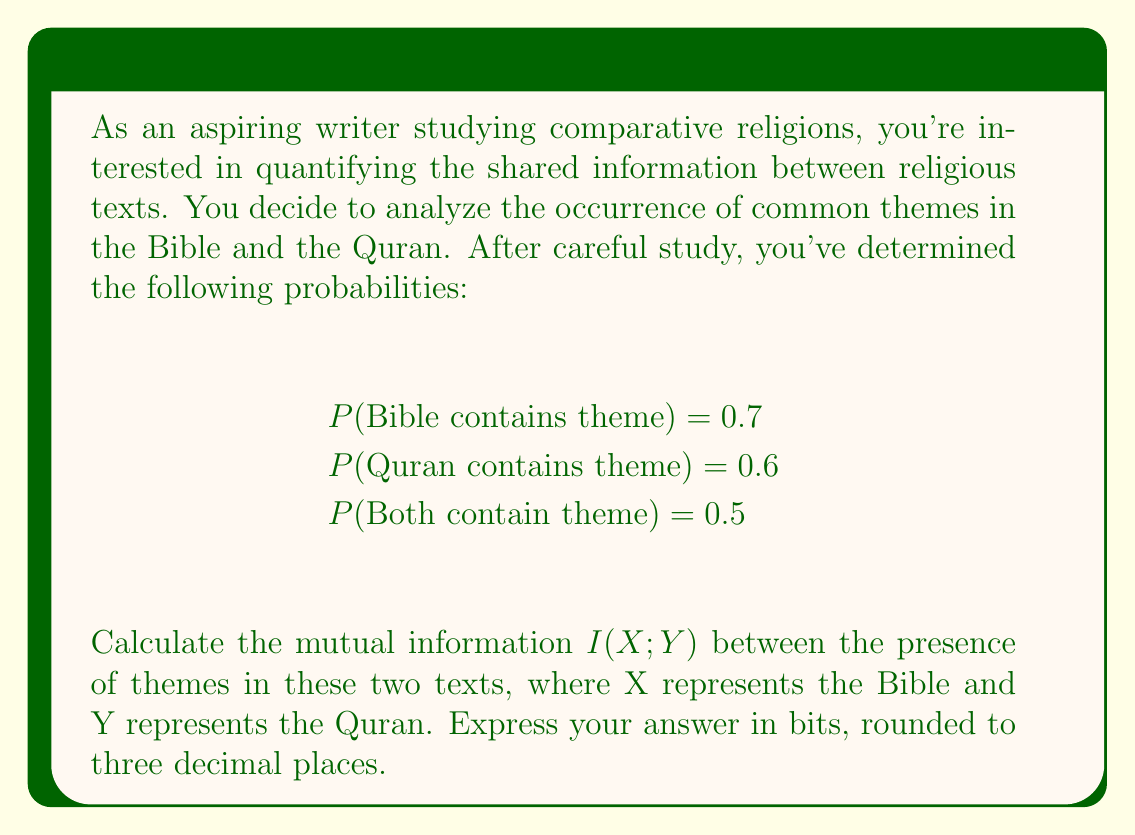Could you help me with this problem? To solve this problem, we'll use the formula for mutual information:

$$I(X;Y) = H(X) + H(Y) - H(X,Y)$$

Where $H(X)$ and $H(Y)$ are the marginal entropies, and $H(X,Y)$ is the joint entropy.

Step 1: Calculate $H(X)$ (entropy of Bible themes)
$$H(X) = -P(X)\log_2P(X) - (1-P(X))\log_2(1-P(X))$$
$$H(X) = -0.7\log_2(0.7) - 0.3\log_2(0.3) = 0.8813 \text{ bits}$$

Step 2: Calculate $H(Y)$ (entropy of Quran themes)
$$H(Y) = -P(Y)\log_2P(Y) - (1-P(Y))\log_2(1-P(Y))$$
$$H(Y) = -0.6\log_2(0.6) - 0.4\log_2(0.4) = 0.9710 \text{ bits}$$

Step 3: Calculate $H(X,Y)$ (joint entropy)
We need to calculate the probabilities for all four possible combinations:
P(Both contain) = 0.5
P(Bible contains, Quran doesn't) = 0.7 - 0.5 = 0.2
P(Quran contains, Bible doesn't) = 0.6 - 0.5 = 0.1
P(Neither contains) = 1 - 0.7 - 0.1 = 0.2

Now we can calculate the joint entropy:
$$H(X,Y) = -\sum_{x,y} P(x,y)\log_2P(x,y)$$
$$H(X,Y) = -0.5\log_2(0.5) - 0.2\log_2(0.2) - 0.1\log_2(0.1) - 0.2\log_2(0.2) = 1.7609 \text{ bits}$$

Step 4: Calculate mutual information
$$I(X;Y) = H(X) + H(Y) - H(X,Y)$$
$$I(X;Y) = 0.8813 + 0.9710 - 1.7609 = 0.0914 \text{ bits}$$

Rounding to three decimal places: 0.091 bits
Answer: 0.091 bits 